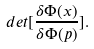<formula> <loc_0><loc_0><loc_500><loc_500>d e t [ \frac { \delta \Phi ( x ) } { \delta \Phi ( p ) } ] .</formula> 